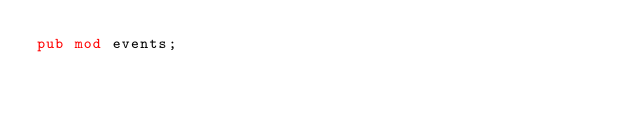Convert code to text. <code><loc_0><loc_0><loc_500><loc_500><_Rust_>pub mod events;</code> 